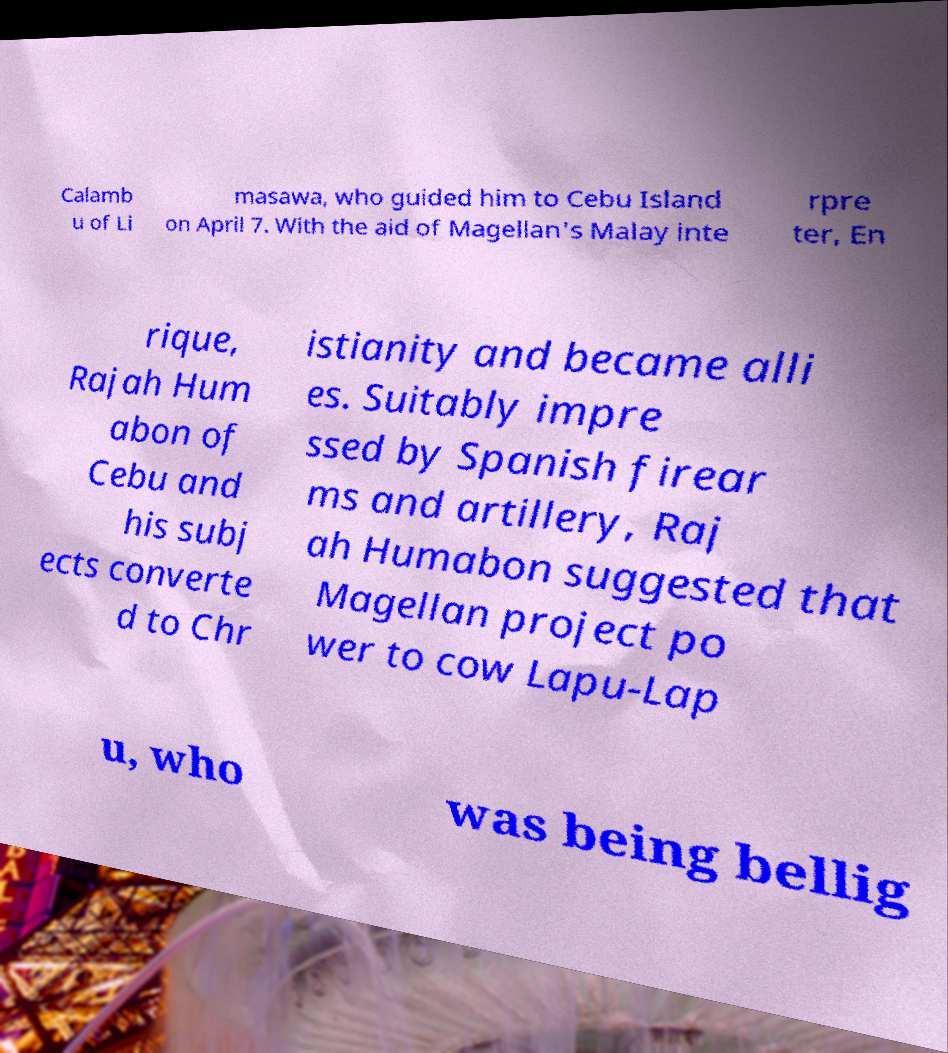Could you assist in decoding the text presented in this image and type it out clearly? Calamb u of Li masawa, who guided him to Cebu Island on April 7. With the aid of Magellan's Malay inte rpre ter, En rique, Rajah Hum abon of Cebu and his subj ects converte d to Chr istianity and became alli es. Suitably impre ssed by Spanish firear ms and artillery, Raj ah Humabon suggested that Magellan project po wer to cow Lapu-Lap u, who was being bellig 